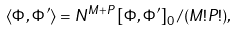Convert formula to latex. <formula><loc_0><loc_0><loc_500><loc_500>\langle \Phi , \Phi ^ { \prime } \rangle = N ^ { M + P } \left [ \Phi , \Phi ^ { \prime } \right ] _ { 0 } / ( M ! P ! ) ,</formula> 